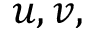Convert formula to latex. <formula><loc_0><loc_0><loc_500><loc_500>u , v ,</formula> 